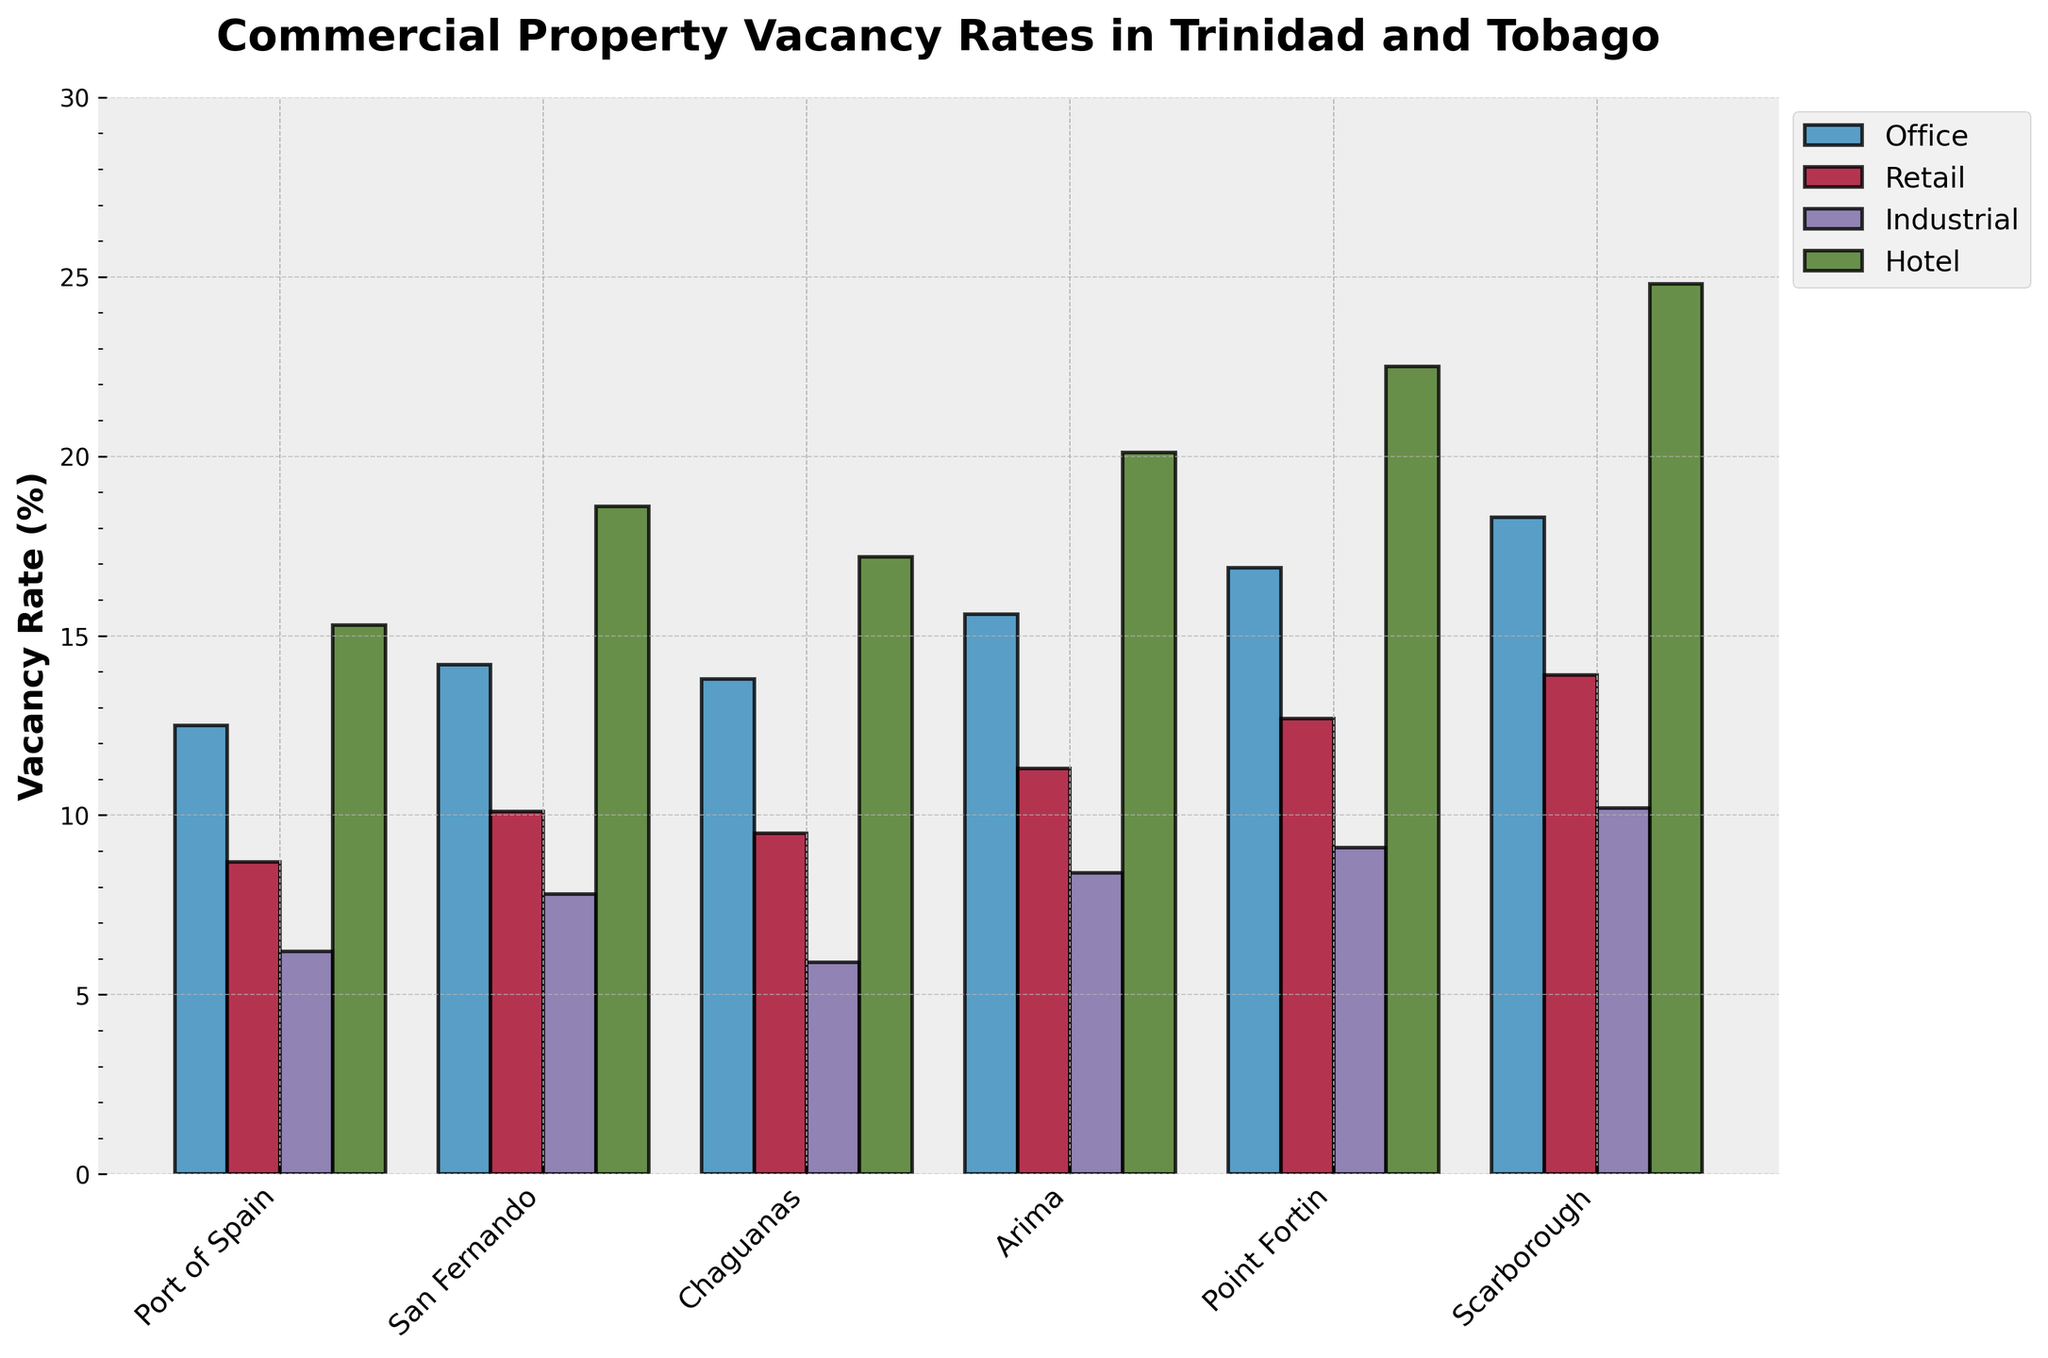What is the vacancy rate for Industrial properties in Chaguanas? Refer to the bar for Industrial properties in Chaguanas, which is the third set of bars from the left and the third bar in the group. The height of the bar indicates the vacancy rate.
Answer: 5.9% Which city has the highest vacancy rate for Hotel properties? Look at the height of the bars representing Hotel properties. The tallest bar in the Hotel category across all cities is for Scarborough.
Answer: Scarborough Compare the vacancy rates for Office properties between Port of Spain and Point Fortin. Which city has a higher rate? Examine the height of the bars for Office properties in both cities. The Office bar in Point Fortin is higher than in Port of Spain.
Answer: Point Fortin What is the average vacancy rate for Retail properties across all cities? Sum the vacancy rates for Retail properties across all cities: (8.7 + 10.1 + 9.5 + 11.3 + 12.7 + 13.9) = 66.2. Then, divide by the number of cities (6). 66.2 / 6 = 11.03.
Answer: 11.03% What is the difference in vacancy rates for Hotel properties between Arima and San Fernando? Look at the bars for Hotel properties in Arima and San Fernando. The rates are 20.1% and 18.6% respectively. Subtract 18.6 from 20.1.
Answer: 1.5% Which property type generally has the lowest vacancy rates across most cities? Visually scan all property types' bars in each city. Industrial properties generally have the shortest bars, indicating lower vacancy rates.
Answer: Industrial How does the vacancy rate for Retail properties in San Fernando compare to Industrial properties in the same city? Compare the height of the bar for Retail properties (10.1%) with that of Industrial properties (7.8%) in San Fernando. Retail is higher.
Answer: Higher What are the combined vacancy rates for Office and Hotel properties in Arima? Add the vacancy rates for Office (15.6%) and Hotel (20.1%) properties in Arima. 15.6 + 20.1 = 35.7.
Answer: 35.7% Which city has the smallest difference in vacancy rates between Office and Retail properties? Calculate the difference between Office and Retail rates in each city: 
Port of Spain (12.5%-8.7% = 3.8), 
San Fernando (14.2%-10.1% = 4.1), 
Chaguanas (13.8%-9.5% = 4.3), 
Arima (15.6%-11.3% = 4.3), 
Point Fortin (16.9%-12.7% = 4.2), 
Scarborough (18.3%-13.9% = 4.4). Port of Spain has the smallest difference of 3.8.
Answer: Port of Spain 